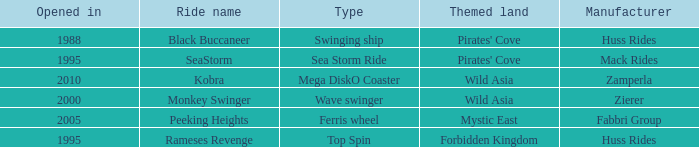What type ride is Wild Asia that opened in 2000? Wave swinger. 